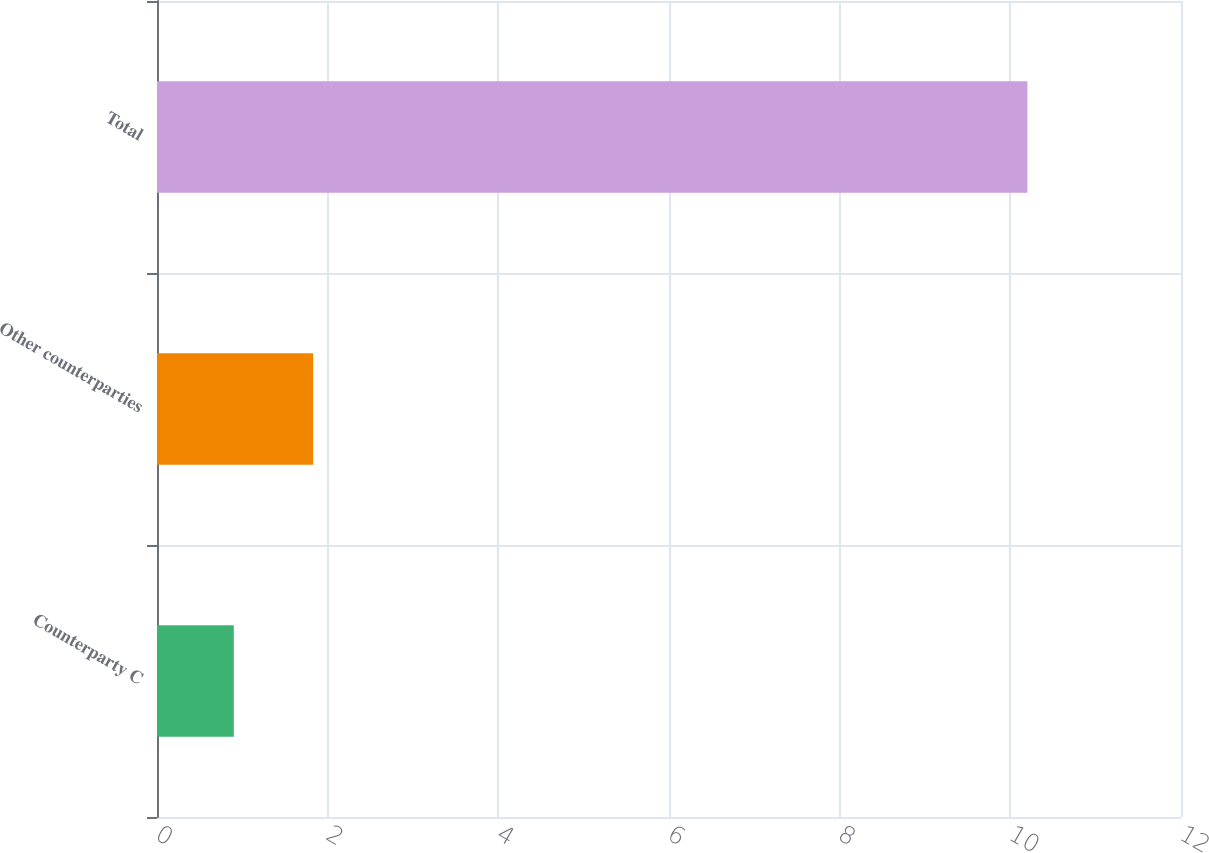Convert chart to OTSL. <chart><loc_0><loc_0><loc_500><loc_500><bar_chart><fcel>Counterparty C<fcel>Other counterparties<fcel>Total<nl><fcel>0.9<fcel>1.83<fcel>10.2<nl></chart> 